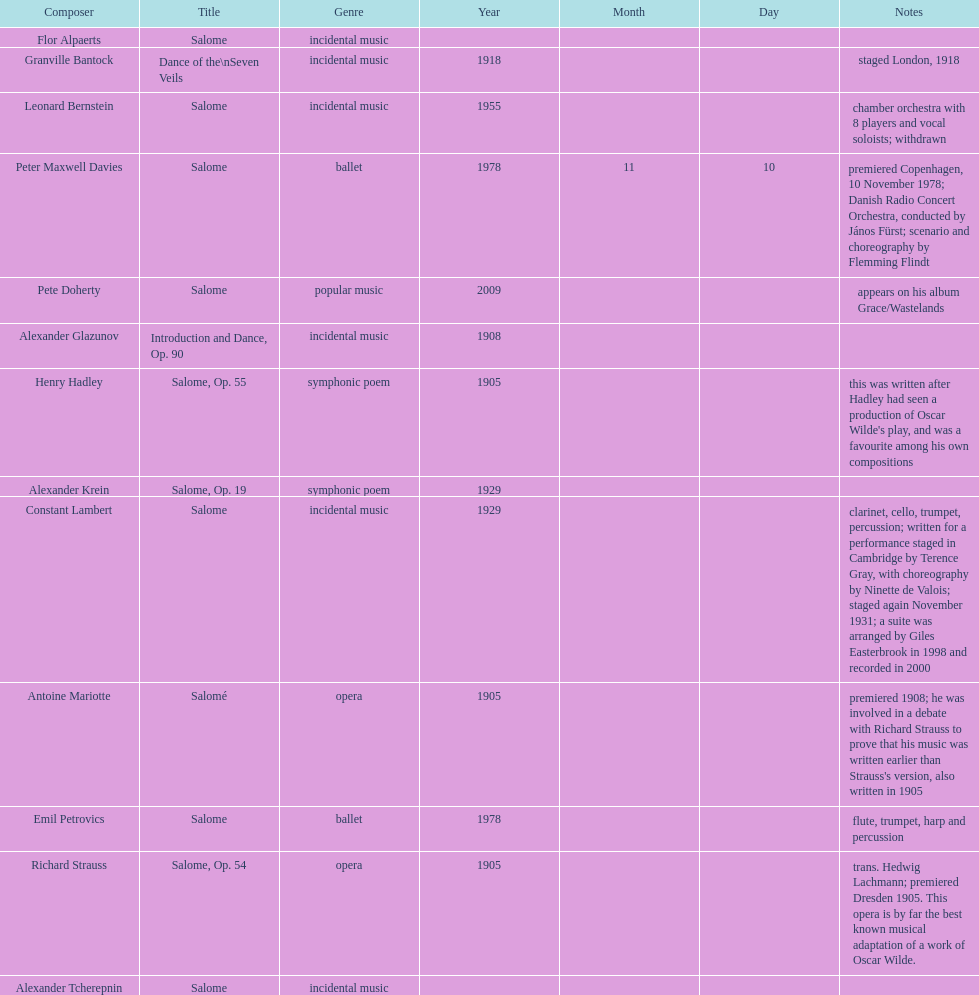How many are symphonic poems? 2. 